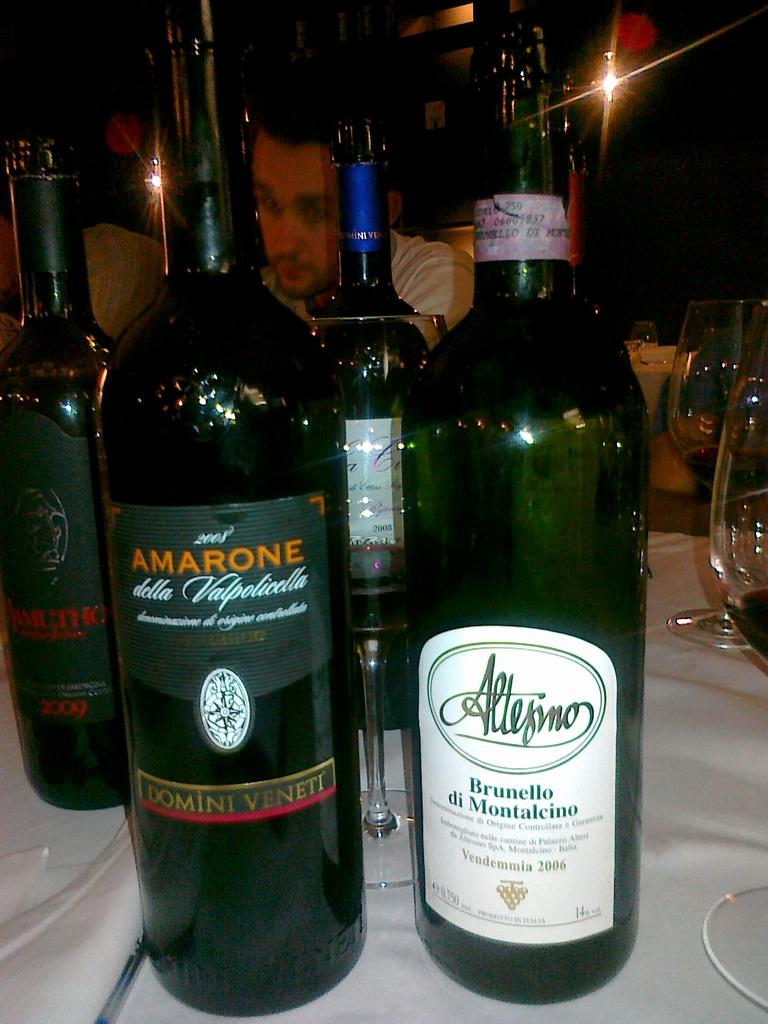What piece of furniture is present in the image? A: There is a table in the image. What items are on the table? There are green color wine bottles and glasses on the table. Is there a person in the image? Yes, there is a person sitting in the image. Where is the monkey sitting in the image? There is no monkey present in the image. 